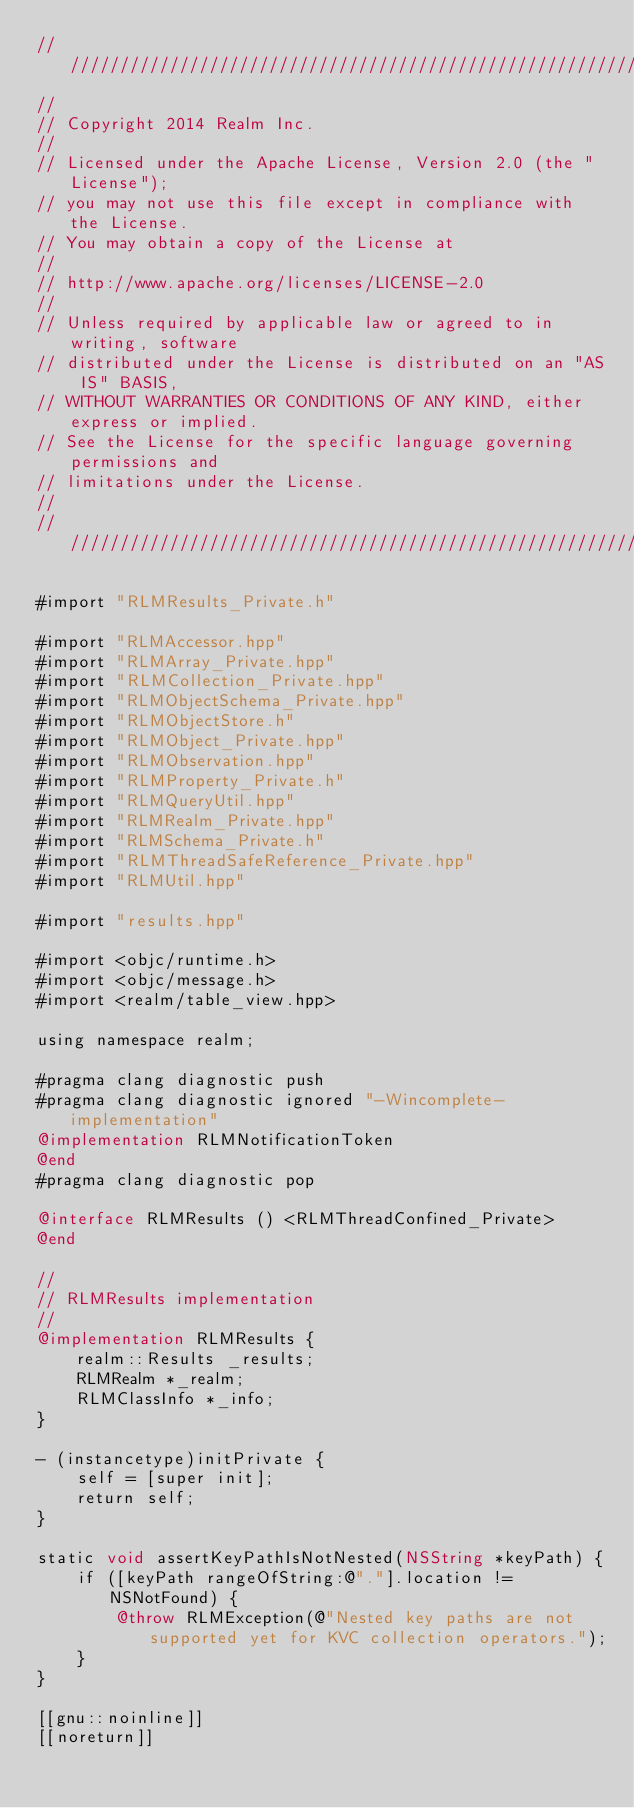<code> <loc_0><loc_0><loc_500><loc_500><_ObjectiveC_>////////////////////////////////////////////////////////////////////////////
//
// Copyright 2014 Realm Inc.
//
// Licensed under the Apache License, Version 2.0 (the "License");
// you may not use this file except in compliance with the License.
// You may obtain a copy of the License at
//
// http://www.apache.org/licenses/LICENSE-2.0
//
// Unless required by applicable law or agreed to in writing, software
// distributed under the License is distributed on an "AS IS" BASIS,
// WITHOUT WARRANTIES OR CONDITIONS OF ANY KIND, either express or implied.
// See the License for the specific language governing permissions and
// limitations under the License.
//
////////////////////////////////////////////////////////////////////////////

#import "RLMResults_Private.h"

#import "RLMAccessor.hpp"
#import "RLMArray_Private.hpp"
#import "RLMCollection_Private.hpp"
#import "RLMObjectSchema_Private.hpp"
#import "RLMObjectStore.h"
#import "RLMObject_Private.hpp"
#import "RLMObservation.hpp"
#import "RLMProperty_Private.h"
#import "RLMQueryUtil.hpp"
#import "RLMRealm_Private.hpp"
#import "RLMSchema_Private.h"
#import "RLMThreadSafeReference_Private.hpp"
#import "RLMUtil.hpp"

#import "results.hpp"

#import <objc/runtime.h>
#import <objc/message.h>
#import <realm/table_view.hpp>

using namespace realm;

#pragma clang diagnostic push
#pragma clang diagnostic ignored "-Wincomplete-implementation"
@implementation RLMNotificationToken
@end
#pragma clang diagnostic pop

@interface RLMResults () <RLMThreadConfined_Private>
@end

//
// RLMResults implementation
//
@implementation RLMResults {
    realm::Results _results;
    RLMRealm *_realm;
    RLMClassInfo *_info;
}

- (instancetype)initPrivate {
    self = [super init];
    return self;
}

static void assertKeyPathIsNotNested(NSString *keyPath) {
    if ([keyPath rangeOfString:@"."].location != NSNotFound) {
        @throw RLMException(@"Nested key paths are not supported yet for KVC collection operators.");
    }
}

[[gnu::noinline]]
[[noreturn]]</code> 